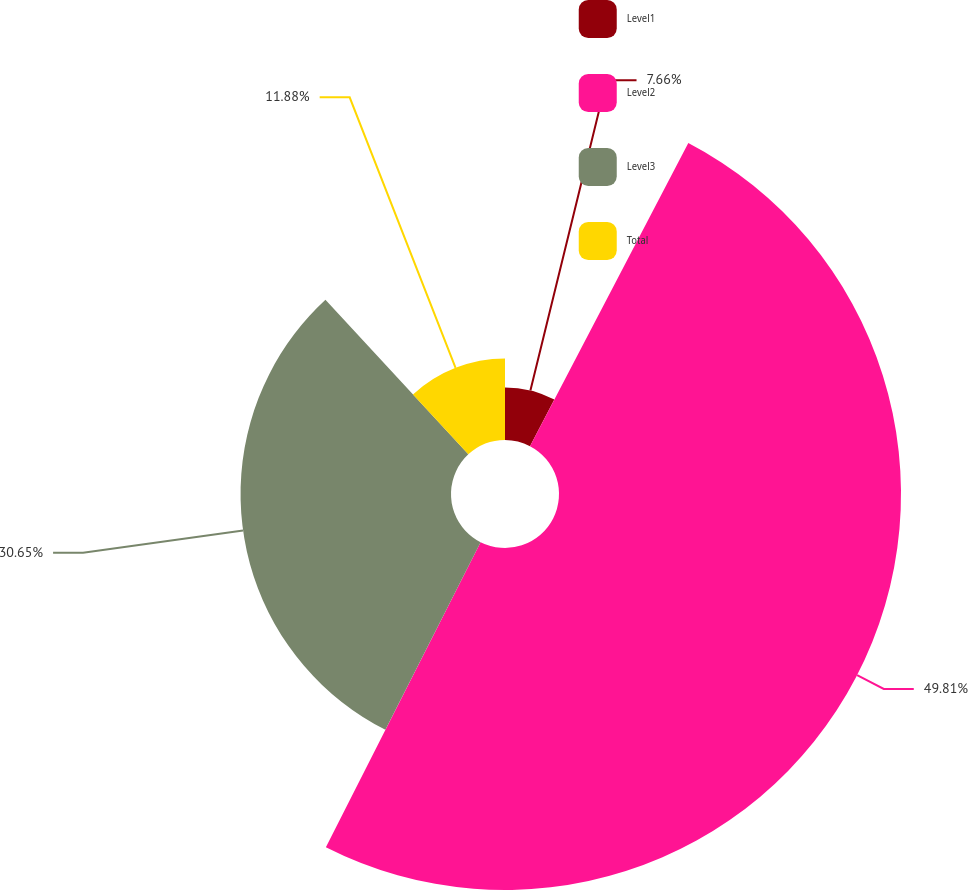Convert chart to OTSL. <chart><loc_0><loc_0><loc_500><loc_500><pie_chart><fcel>Level1<fcel>Level2<fcel>Level3<fcel>Total<nl><fcel>7.66%<fcel>49.81%<fcel>30.65%<fcel>11.88%<nl></chart> 